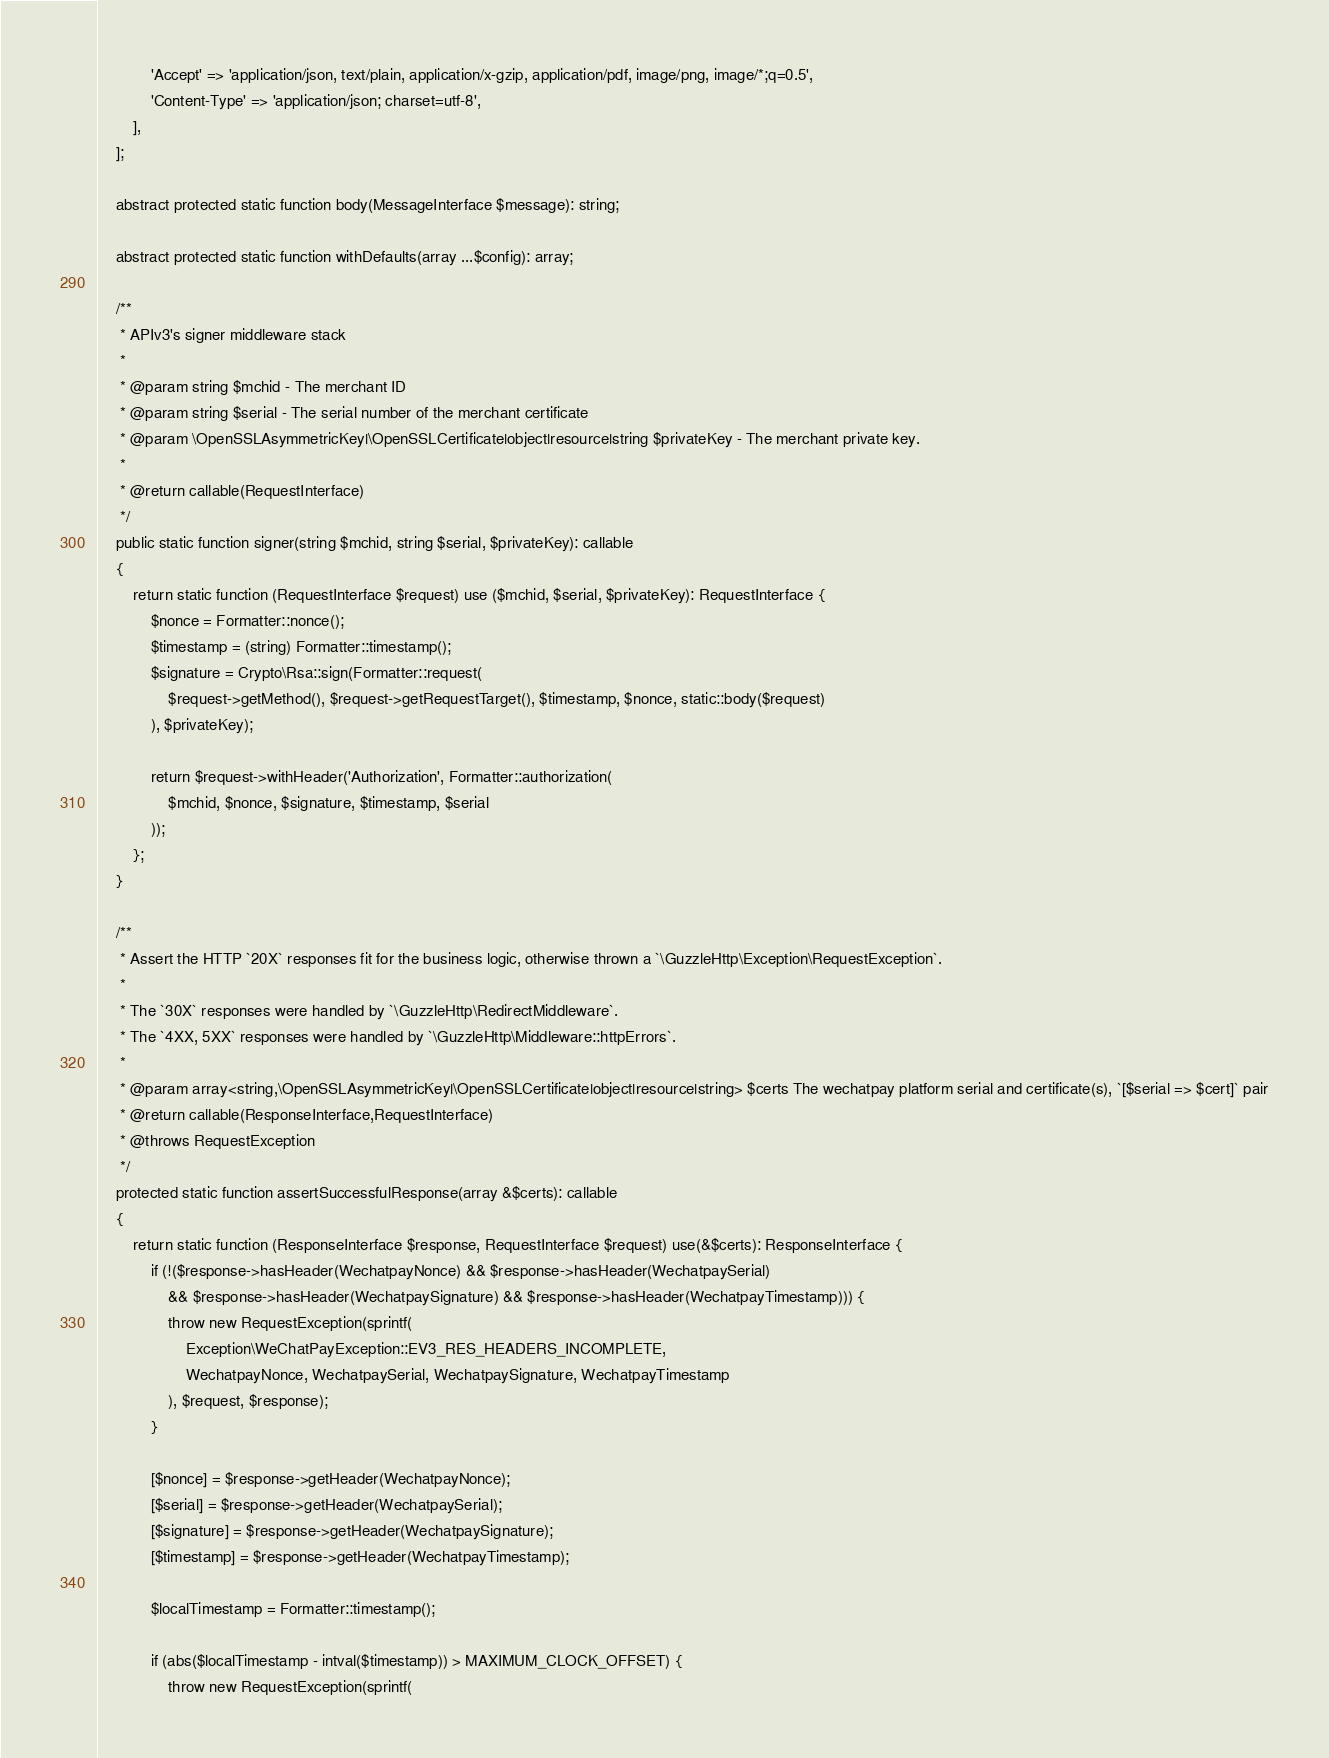Convert code to text. <code><loc_0><loc_0><loc_500><loc_500><_PHP_>            'Accept' => 'application/json, text/plain, application/x-gzip, application/pdf, image/png, image/*;q=0.5',
            'Content-Type' => 'application/json; charset=utf-8',
        ],
    ];

    abstract protected static function body(MessageInterface $message): string;

    abstract protected static function withDefaults(array ...$config): array;

    /**
     * APIv3's signer middleware stack
     *
     * @param string $mchid - The merchant ID
     * @param string $serial - The serial number of the merchant certificate
     * @param \OpenSSLAsymmetricKey|\OpenSSLCertificate|object|resource|string $privateKey - The merchant private key.
     *
     * @return callable(RequestInterface)
     */
    public static function signer(string $mchid, string $serial, $privateKey): callable
    {
        return static function (RequestInterface $request) use ($mchid, $serial, $privateKey): RequestInterface {
            $nonce = Formatter::nonce();
            $timestamp = (string) Formatter::timestamp();
            $signature = Crypto\Rsa::sign(Formatter::request(
                $request->getMethod(), $request->getRequestTarget(), $timestamp, $nonce, static::body($request)
            ), $privateKey);

            return $request->withHeader('Authorization', Formatter::authorization(
                $mchid, $nonce, $signature, $timestamp, $serial
            ));
        };
    }

    /**
     * Assert the HTTP `20X` responses fit for the business logic, otherwise thrown a `\GuzzleHttp\Exception\RequestException`.
     *
     * The `30X` responses were handled by `\GuzzleHttp\RedirectMiddleware`.
     * The `4XX, 5XX` responses were handled by `\GuzzleHttp\Middleware::httpErrors`.
     *
     * @param array<string,\OpenSSLAsymmetricKey|\OpenSSLCertificate|object|resource|string> $certs The wechatpay platform serial and certificate(s), `[$serial => $cert]` pair
     * @return callable(ResponseInterface,RequestInterface)
     * @throws RequestException
     */
    protected static function assertSuccessfulResponse(array &$certs): callable
    {
        return static function (ResponseInterface $response, RequestInterface $request) use(&$certs): ResponseInterface {
            if (!($response->hasHeader(WechatpayNonce) && $response->hasHeader(WechatpaySerial)
                && $response->hasHeader(WechatpaySignature) && $response->hasHeader(WechatpayTimestamp))) {
                throw new RequestException(sprintf(
                    Exception\WeChatPayException::EV3_RES_HEADERS_INCOMPLETE,
                    WechatpayNonce, WechatpaySerial, WechatpaySignature, WechatpayTimestamp
                ), $request, $response);
            }

            [$nonce] = $response->getHeader(WechatpayNonce);
            [$serial] = $response->getHeader(WechatpaySerial);
            [$signature] = $response->getHeader(WechatpaySignature);
            [$timestamp] = $response->getHeader(WechatpayTimestamp);

            $localTimestamp = Formatter::timestamp();

            if (abs($localTimestamp - intval($timestamp)) > MAXIMUM_CLOCK_OFFSET) {
                throw new RequestException(sprintf(</code> 